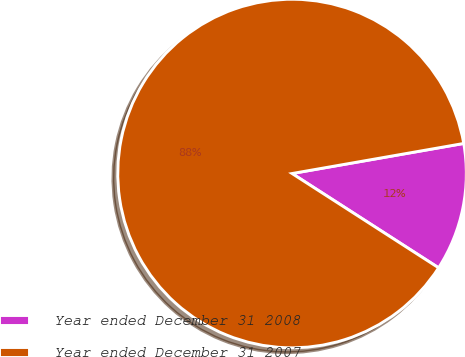Convert chart to OTSL. <chart><loc_0><loc_0><loc_500><loc_500><pie_chart><fcel>Year ended December 31 2008<fcel>Year ended December 31 2007<nl><fcel>11.86%<fcel>88.14%<nl></chart> 